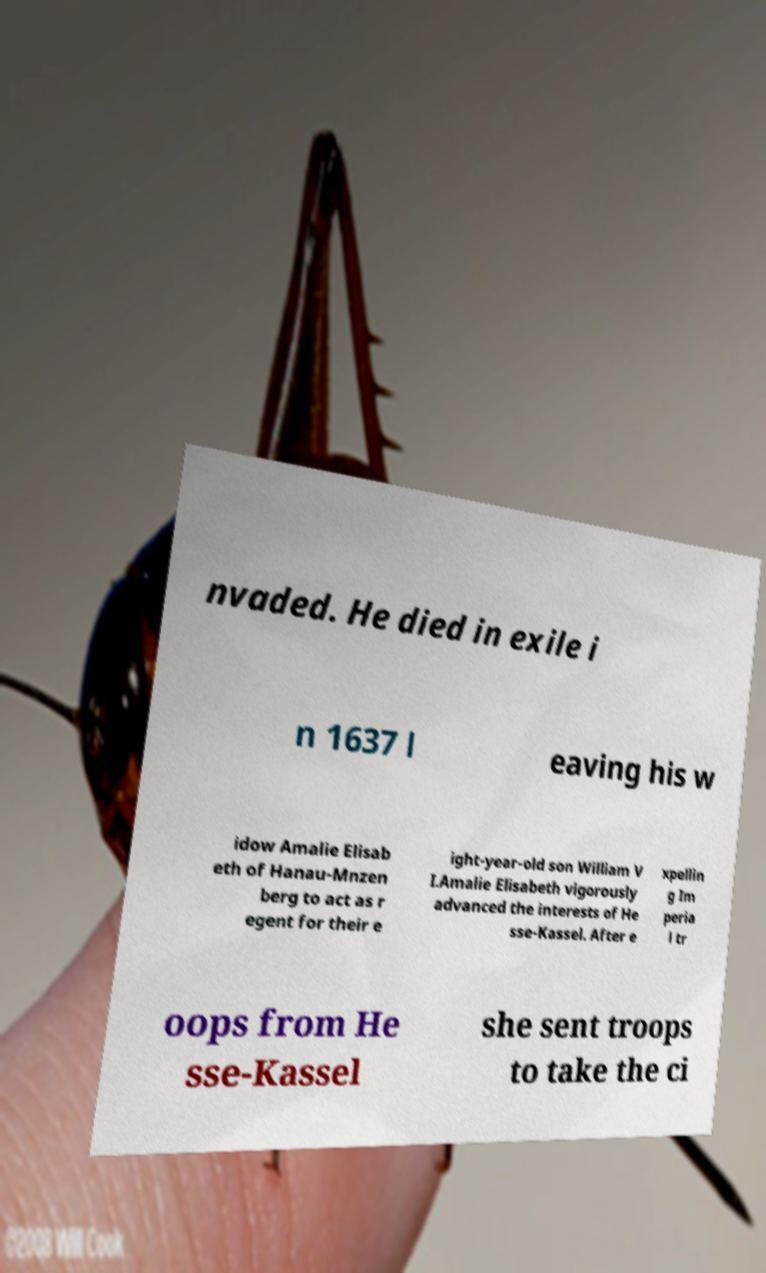Could you extract and type out the text from this image? nvaded. He died in exile i n 1637 l eaving his w idow Amalie Elisab eth of Hanau-Mnzen berg to act as r egent for their e ight-year-old son William V I.Amalie Elisabeth vigorously advanced the interests of He sse-Kassel. After e xpellin g Im peria l tr oops from He sse-Kassel she sent troops to take the ci 